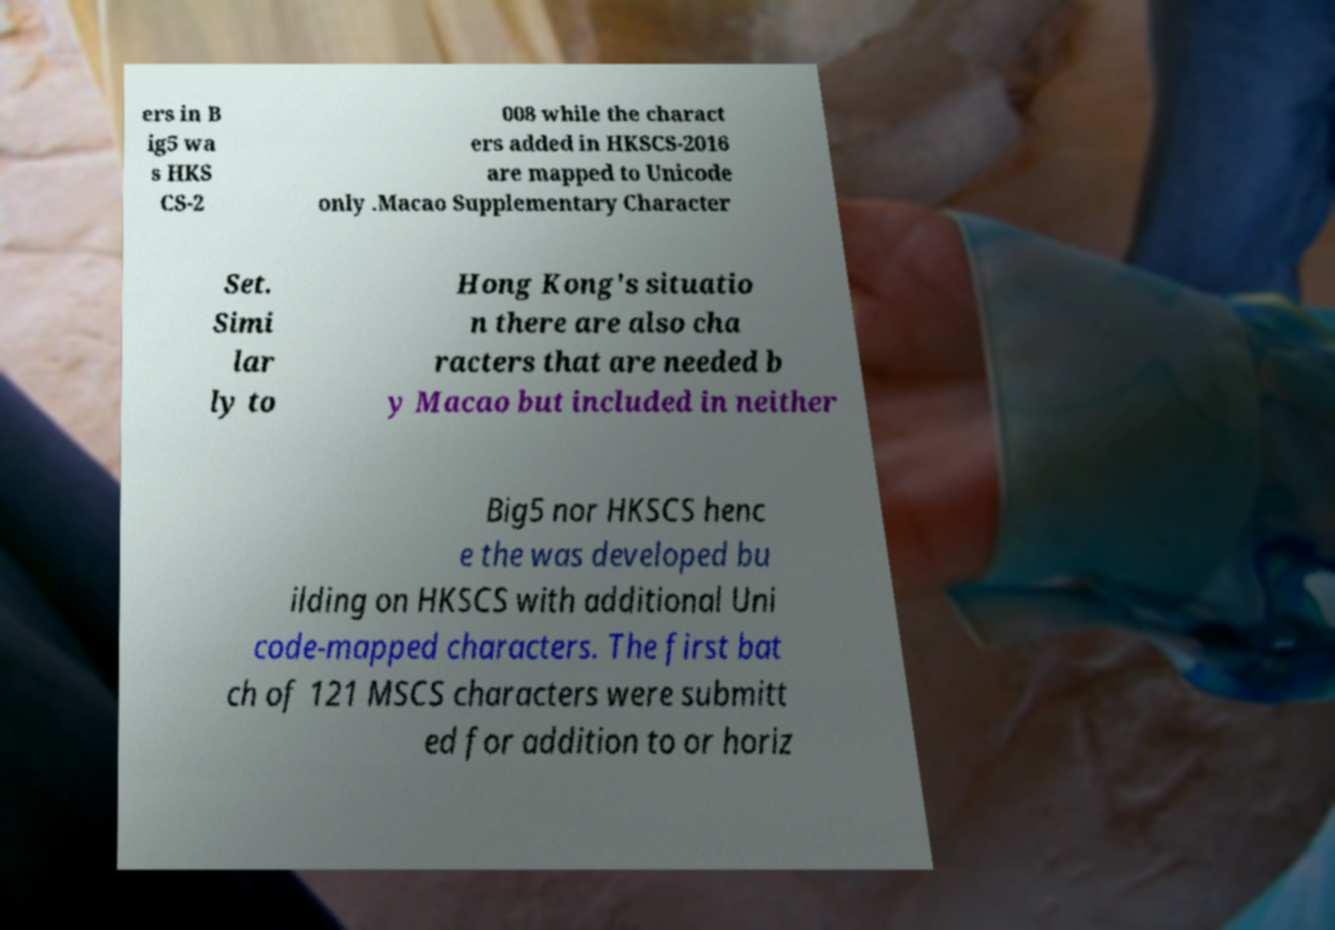Could you assist in decoding the text presented in this image and type it out clearly? ers in B ig5 wa s HKS CS-2 008 while the charact ers added in HKSCS-2016 are mapped to Unicode only .Macao Supplementary Character Set. Simi lar ly to Hong Kong's situatio n there are also cha racters that are needed b y Macao but included in neither Big5 nor HKSCS henc e the was developed bu ilding on HKSCS with additional Uni code-mapped characters. The first bat ch of 121 MSCS characters were submitt ed for addition to or horiz 